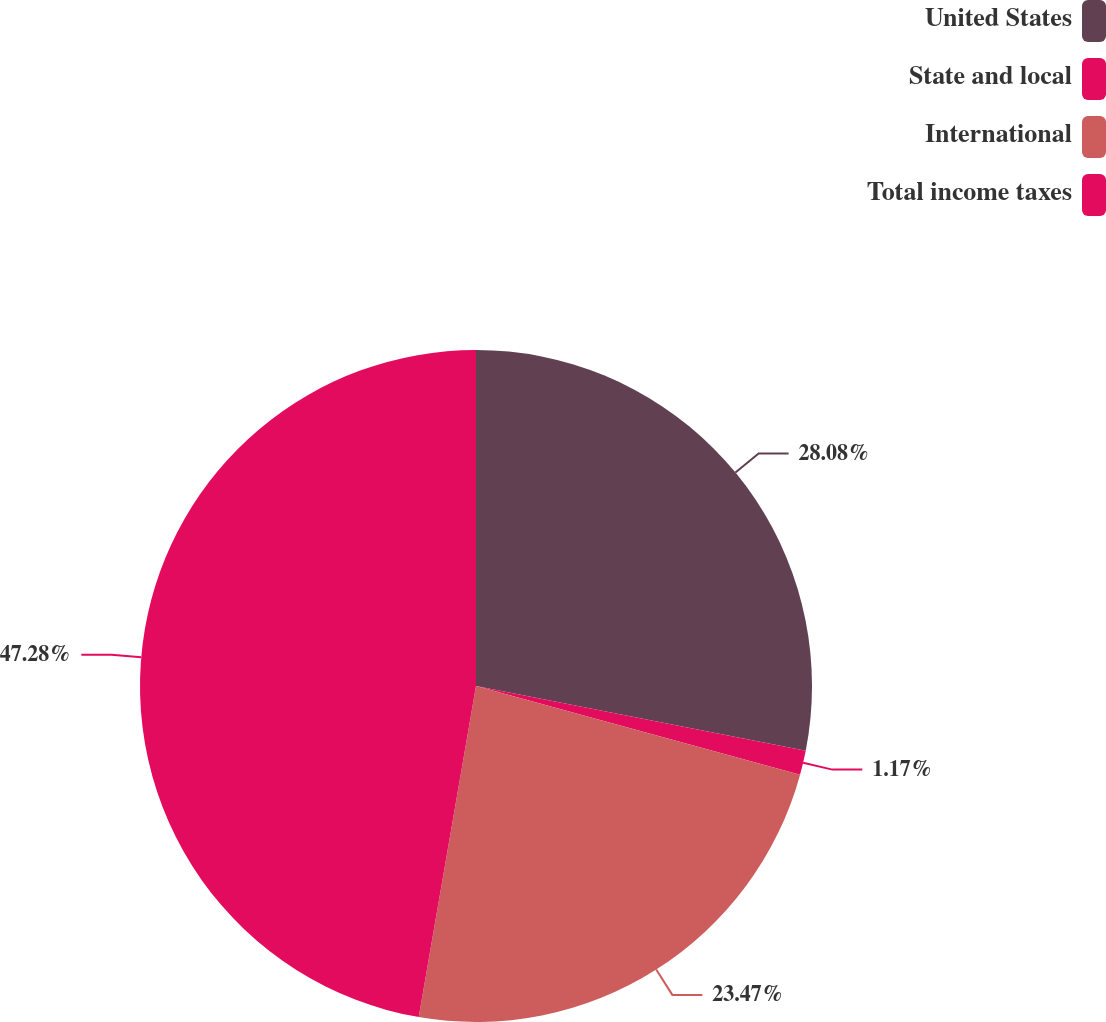Convert chart to OTSL. <chart><loc_0><loc_0><loc_500><loc_500><pie_chart><fcel>United States<fcel>State and local<fcel>International<fcel>Total income taxes<nl><fcel>28.08%<fcel>1.17%<fcel>23.47%<fcel>47.27%<nl></chart> 